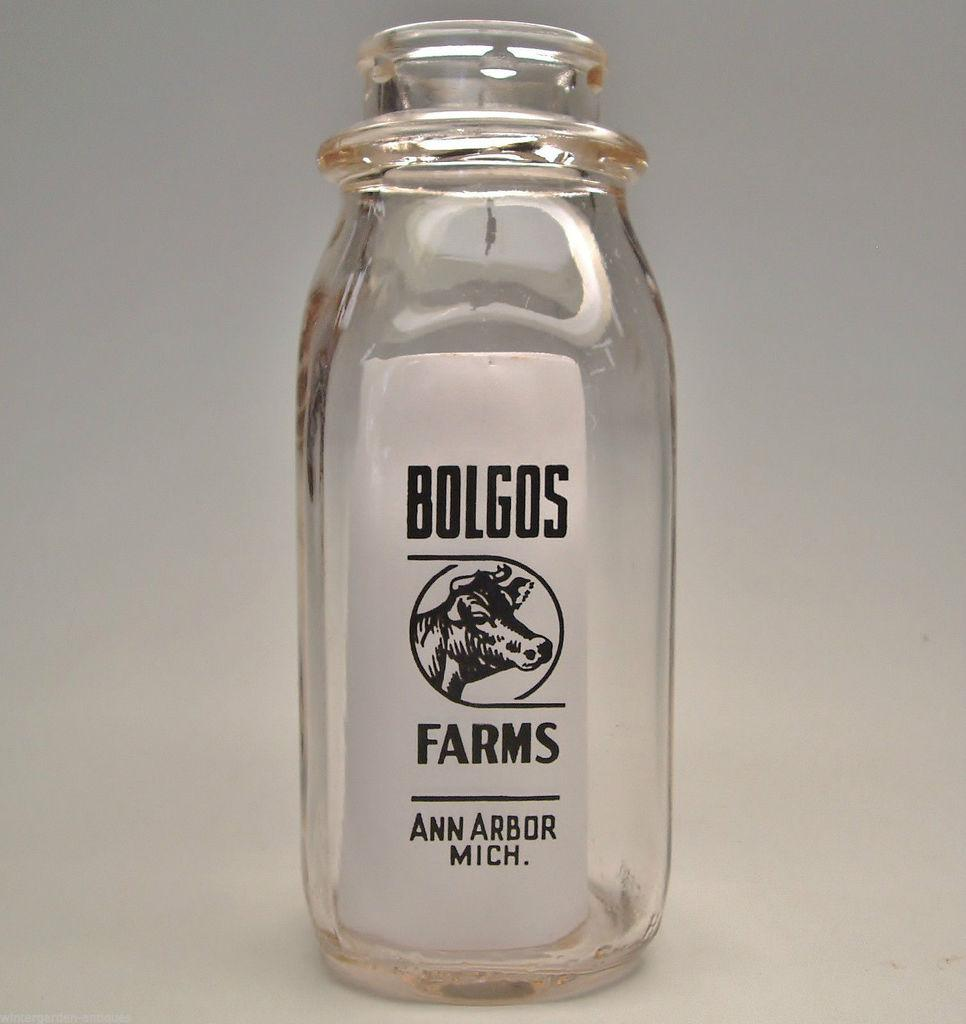<image>
Create a compact narrative representing the image presented. Bolgos farms from Ann Arbor Mich clear jar. 